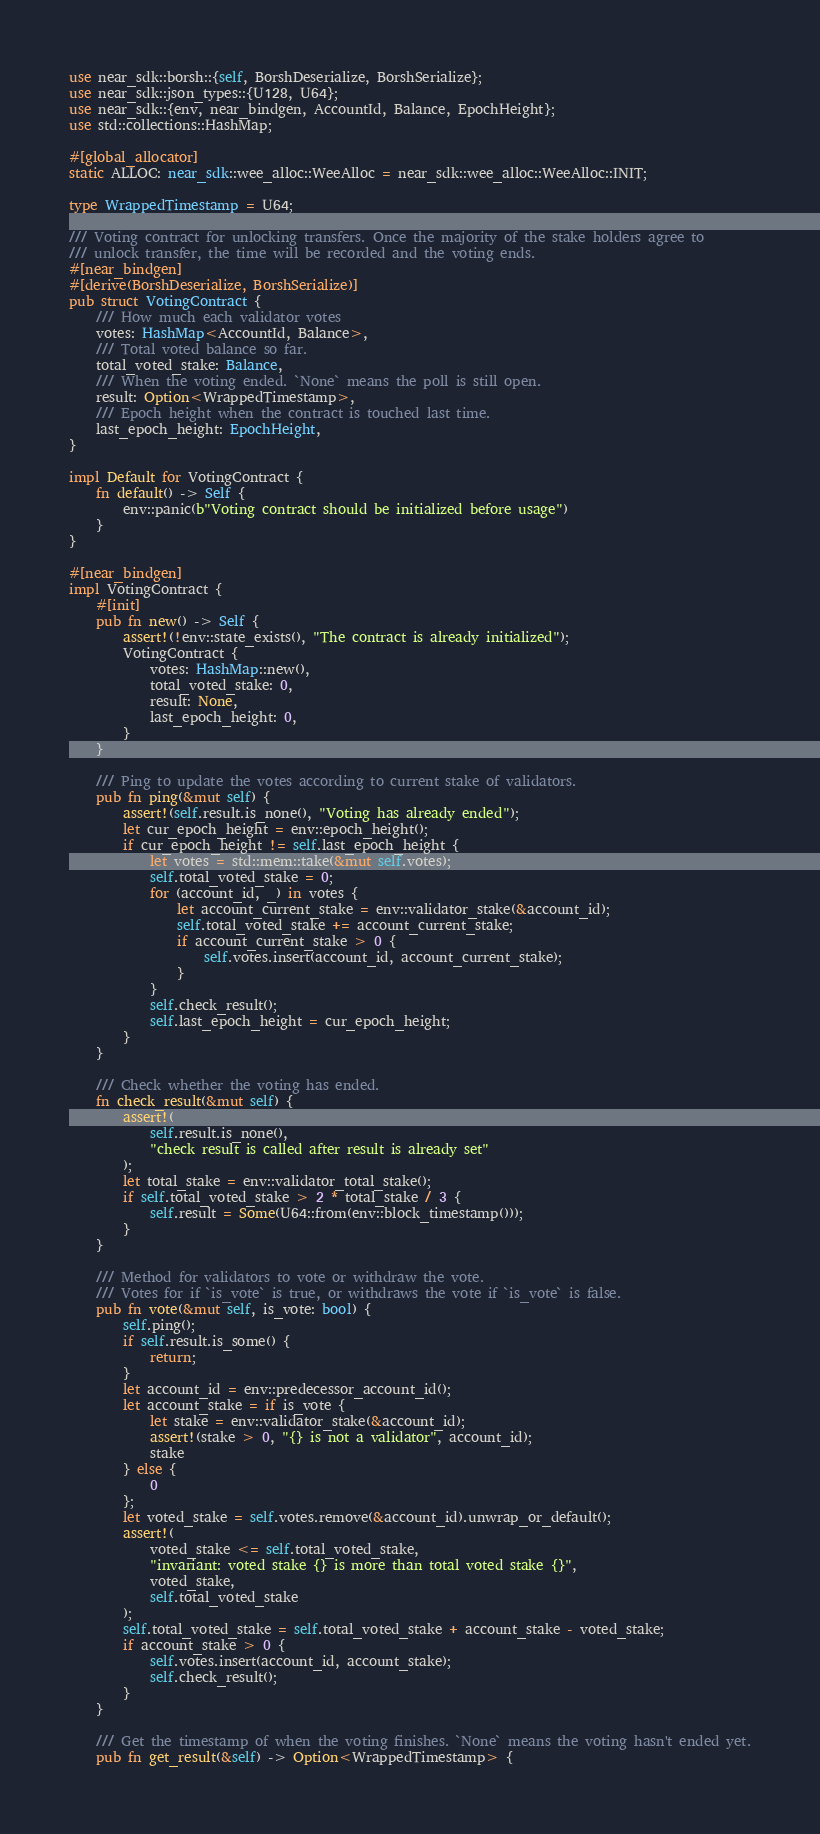Convert code to text. <code><loc_0><loc_0><loc_500><loc_500><_Rust_>use near_sdk::borsh::{self, BorshDeserialize, BorshSerialize};
use near_sdk::json_types::{U128, U64};
use near_sdk::{env, near_bindgen, AccountId, Balance, EpochHeight};
use std::collections::HashMap;

#[global_allocator]
static ALLOC: near_sdk::wee_alloc::WeeAlloc = near_sdk::wee_alloc::WeeAlloc::INIT;

type WrappedTimestamp = U64;

/// Voting contract for unlocking transfers. Once the majority of the stake holders agree to
/// unlock transfer, the time will be recorded and the voting ends.
#[near_bindgen]
#[derive(BorshDeserialize, BorshSerialize)]
pub struct VotingContract {
    /// How much each validator votes
    votes: HashMap<AccountId, Balance>,
    /// Total voted balance so far.
    total_voted_stake: Balance,
    /// When the voting ended. `None` means the poll is still open.
    result: Option<WrappedTimestamp>,
    /// Epoch height when the contract is touched last time.
    last_epoch_height: EpochHeight,
}

impl Default for VotingContract {
    fn default() -> Self {
        env::panic(b"Voting contract should be initialized before usage")
    }
}

#[near_bindgen]
impl VotingContract {
    #[init]
    pub fn new() -> Self {
        assert!(!env::state_exists(), "The contract is already initialized");
        VotingContract {
            votes: HashMap::new(),
            total_voted_stake: 0,
            result: None,
            last_epoch_height: 0,
        }
    }

    /// Ping to update the votes according to current stake of validators.
    pub fn ping(&mut self) {
        assert!(self.result.is_none(), "Voting has already ended");
        let cur_epoch_height = env::epoch_height();
        if cur_epoch_height != self.last_epoch_height {
            let votes = std::mem::take(&mut self.votes);
            self.total_voted_stake = 0;
            for (account_id, _) in votes {
                let account_current_stake = env::validator_stake(&account_id);
                self.total_voted_stake += account_current_stake;
                if account_current_stake > 0 {
                    self.votes.insert(account_id, account_current_stake);
                }
            }
            self.check_result();
            self.last_epoch_height = cur_epoch_height;
        }
    }

    /// Check whether the voting has ended.
    fn check_result(&mut self) {
        assert!(
            self.result.is_none(),
            "check result is called after result is already set"
        );
        let total_stake = env::validator_total_stake();
        if self.total_voted_stake > 2 * total_stake / 3 {
            self.result = Some(U64::from(env::block_timestamp()));
        }
    }

    /// Method for validators to vote or withdraw the vote.
    /// Votes for if `is_vote` is true, or withdraws the vote if `is_vote` is false.
    pub fn vote(&mut self, is_vote: bool) {
        self.ping();
        if self.result.is_some() {
            return;
        }
        let account_id = env::predecessor_account_id();
        let account_stake = if is_vote {
            let stake = env::validator_stake(&account_id);
            assert!(stake > 0, "{} is not a validator", account_id);
            stake
        } else {
            0
        };
        let voted_stake = self.votes.remove(&account_id).unwrap_or_default();
        assert!(
            voted_stake <= self.total_voted_stake,
            "invariant: voted stake {} is more than total voted stake {}",
            voted_stake,
            self.total_voted_stake
        );
        self.total_voted_stake = self.total_voted_stake + account_stake - voted_stake;
        if account_stake > 0 {
            self.votes.insert(account_id, account_stake);
            self.check_result();
        }
    }

    /// Get the timestamp of when the voting finishes. `None` means the voting hasn't ended yet.
    pub fn get_result(&self) -> Option<WrappedTimestamp> {</code> 